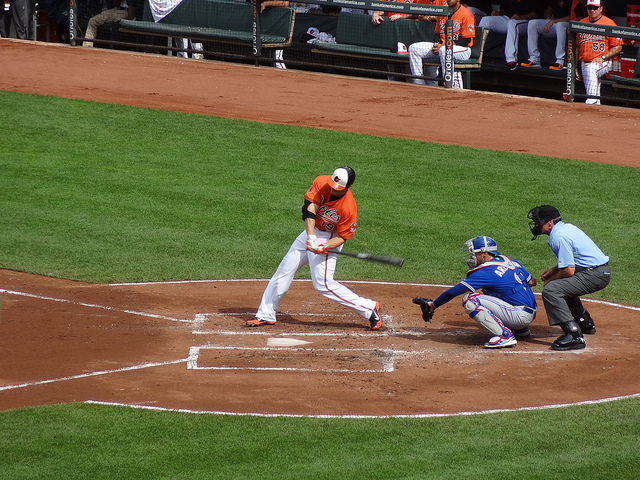Which team could be at home given the colors of the uniforms? Based on the orange jersey of the batter, it suggests that the home team could be a team whose colors include orange, however, without any specific logos or additional context, it's not possible to determine the exact team. 